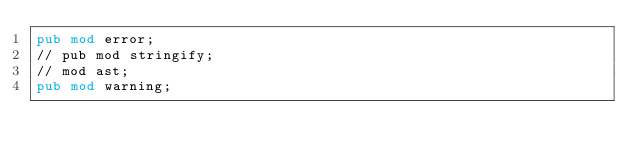Convert code to text. <code><loc_0><loc_0><loc_500><loc_500><_Rust_>pub mod error;
// pub mod stringify;
// mod ast;
pub mod warning;
</code> 